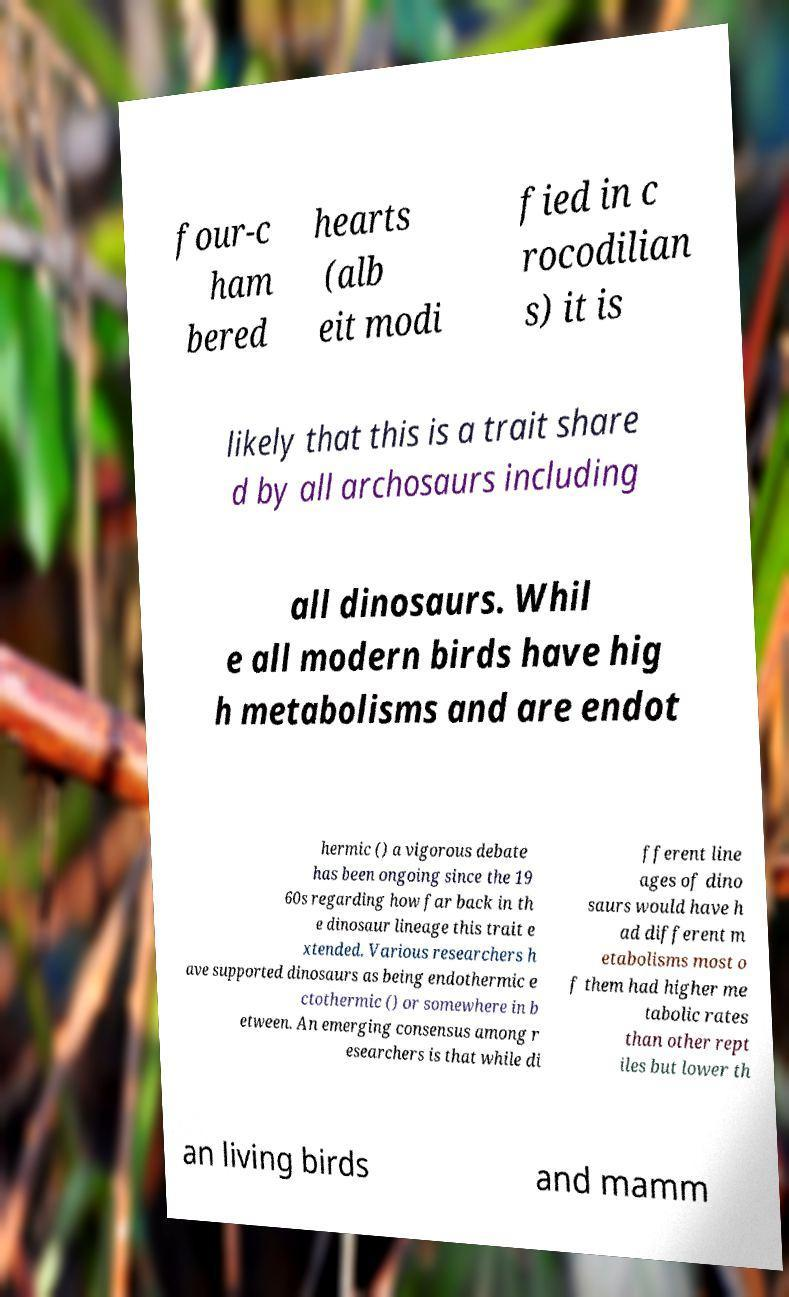I need the written content from this picture converted into text. Can you do that? four-c ham bered hearts (alb eit modi fied in c rocodilian s) it is likely that this is a trait share d by all archosaurs including all dinosaurs. Whil e all modern birds have hig h metabolisms and are endot hermic () a vigorous debate has been ongoing since the 19 60s regarding how far back in th e dinosaur lineage this trait e xtended. Various researchers h ave supported dinosaurs as being endothermic e ctothermic () or somewhere in b etween. An emerging consensus among r esearchers is that while di fferent line ages of dino saurs would have h ad different m etabolisms most o f them had higher me tabolic rates than other rept iles but lower th an living birds and mamm 